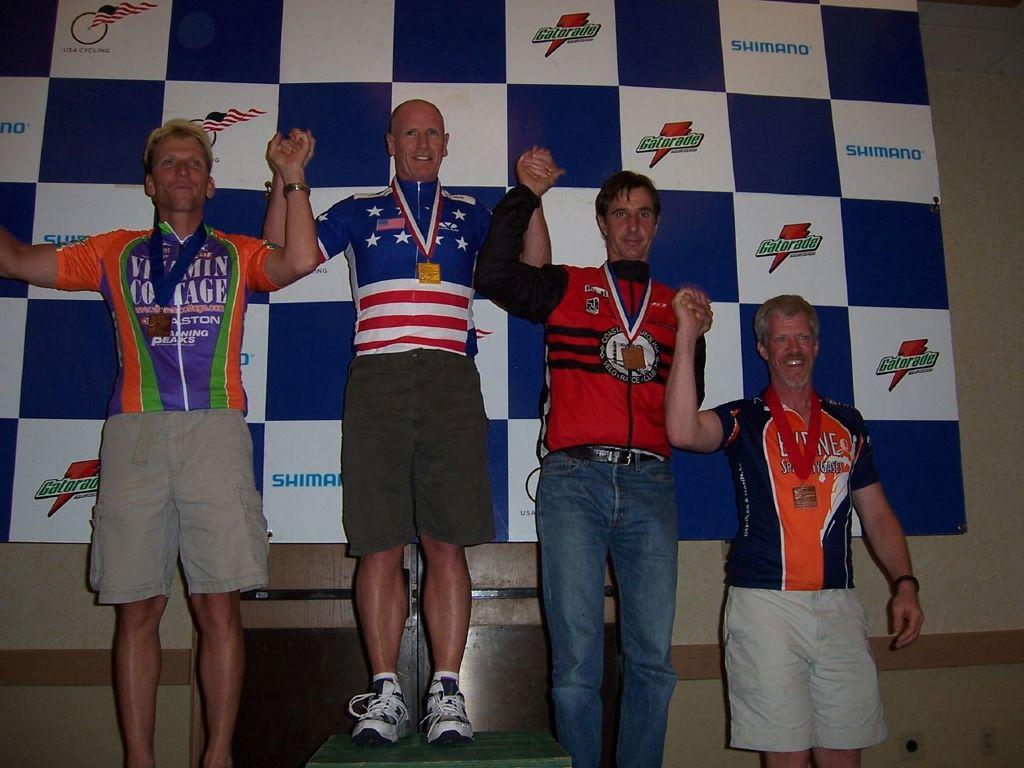<image>
Render a clear and concise summary of the photo. Four cycling champions hold hands in front of a checkered background that advertises for gatorade. 